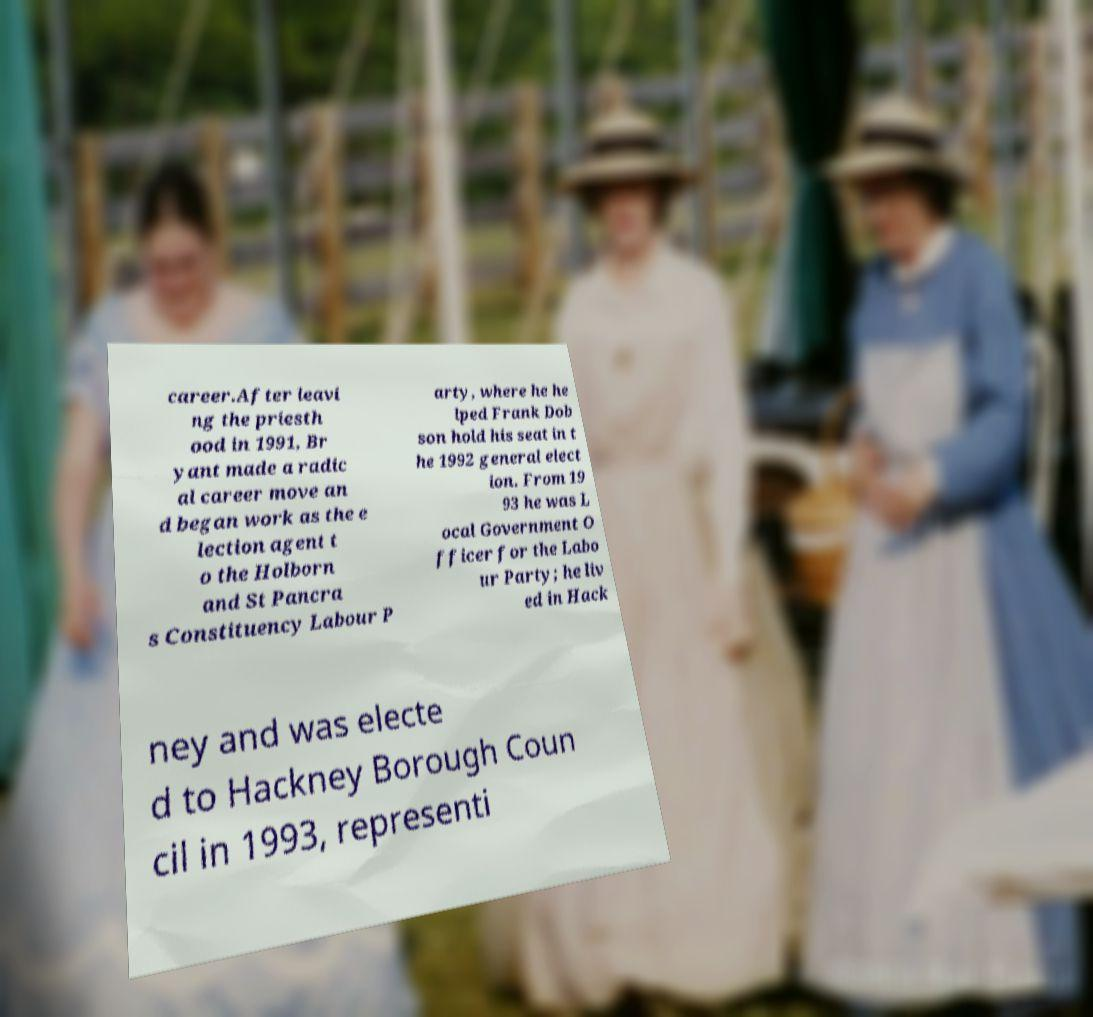What messages or text are displayed in this image? I need them in a readable, typed format. career.After leavi ng the priesth ood in 1991, Br yant made a radic al career move an d began work as the e lection agent t o the Holborn and St Pancra s Constituency Labour P arty, where he he lped Frank Dob son hold his seat in t he 1992 general elect ion. From 19 93 he was L ocal Government O fficer for the Labo ur Party; he liv ed in Hack ney and was electe d to Hackney Borough Coun cil in 1993, representi 